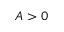Convert formula to latex. <formula><loc_0><loc_0><loc_500><loc_500>A > 0</formula> 